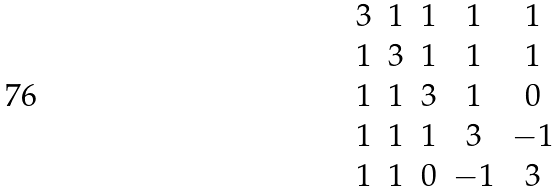Convert formula to latex. <formula><loc_0><loc_0><loc_500><loc_500>\begin{matrix} 3 & 1 & 1 & 1 & 1 \\ 1 & 3 & 1 & 1 & 1 \\ 1 & 1 & 3 & 1 & 0 \\ 1 & 1 & 1 & 3 & - 1 \\ 1 & 1 & 0 & - 1 & 3 \end{matrix}</formula> 